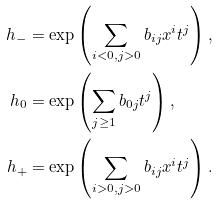Convert formula to latex. <formula><loc_0><loc_0><loc_500><loc_500>h _ { - } & = \exp \left ( \sum _ { i < 0 , j > 0 } b _ { i j } x ^ { i } t ^ { j } \right ) , \\ h _ { 0 } & = \exp \left ( \sum _ { j \geq 1 } b _ { 0 j } t ^ { j } \right ) , \\ h _ { + } & = \exp \left ( \sum _ { i > 0 , j > 0 } b _ { i j } x ^ { i } t ^ { j } \right ) .</formula> 